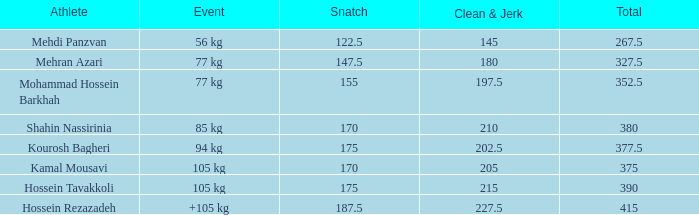5? 0.0. 